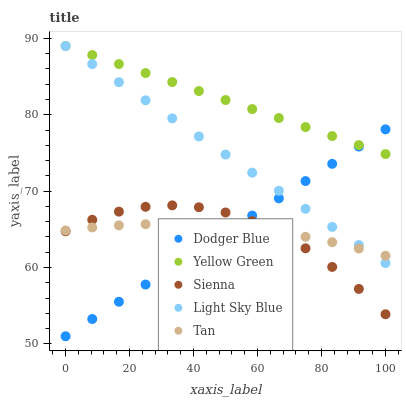Does Sienna have the minimum area under the curve?
Answer yes or no. Yes. Does Yellow Green have the maximum area under the curve?
Answer yes or no. Yes. Does Tan have the minimum area under the curve?
Answer yes or no. No. Does Tan have the maximum area under the curve?
Answer yes or no. No. Is Dodger Blue the smoothest?
Answer yes or no. Yes. Is Sienna the roughest?
Answer yes or no. Yes. Is Tan the smoothest?
Answer yes or no. No. Is Tan the roughest?
Answer yes or no. No. Does Dodger Blue have the lowest value?
Answer yes or no. Yes. Does Tan have the lowest value?
Answer yes or no. No. Does Yellow Green have the highest value?
Answer yes or no. Yes. Does Tan have the highest value?
Answer yes or no. No. Is Tan less than Yellow Green?
Answer yes or no. Yes. Is Yellow Green greater than Tan?
Answer yes or no. Yes. Does Tan intersect Light Sky Blue?
Answer yes or no. Yes. Is Tan less than Light Sky Blue?
Answer yes or no. No. Is Tan greater than Light Sky Blue?
Answer yes or no. No. Does Tan intersect Yellow Green?
Answer yes or no. No. 